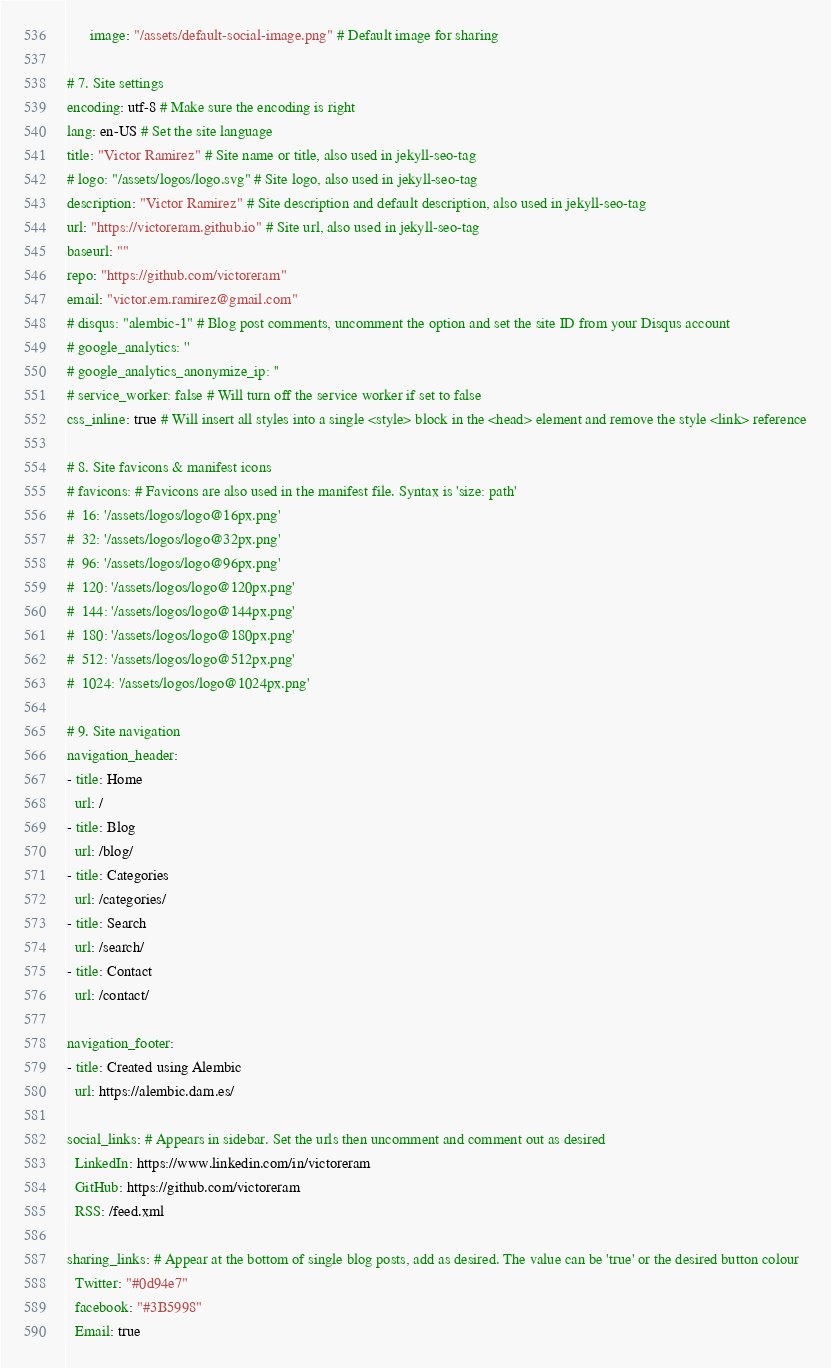<code> <loc_0><loc_0><loc_500><loc_500><_YAML_>      image: "/assets/default-social-image.png" # Default image for sharing

# 7. Site settings
encoding: utf-8 # Make sure the encoding is right
lang: en-US # Set the site language
title: "Victor Ramirez" # Site name or title, also used in jekyll-seo-tag
# logo: "/assets/logos/logo.svg" # Site logo, also used in jekyll-seo-tag
description: "Victor Ramirez" # Site description and default description, also used in jekyll-seo-tag
url: "https://victoreram.github.io" # Site url, also used in jekyll-seo-tag
baseurl: ""
repo: "https://github.com/victoreram"
email: "victor.em.ramirez@gmail.com"
# disqus: "alembic-1" # Blog post comments, uncomment the option and set the site ID from your Disqus account
# google_analytics: ''
# google_analytics_anonymize_ip: ''
# service_worker: false # Will turn off the service worker if set to false
css_inline: true # Will insert all styles into a single <style> block in the <head> element and remove the style <link> reference

# 8. Site favicons & manifest icons
# favicons: # Favicons are also used in the manifest file. Syntax is 'size: path'
#  16: '/assets/logos/logo@16px.png'
#  32: '/assets/logos/logo@32px.png'
#  96: '/assets/logos/logo@96px.png'
#  120: '/assets/logos/logo@120px.png'
#  144: '/assets/logos/logo@144px.png'
#  180: '/assets/logos/logo@180px.png'
#  512: '/assets/logos/logo@512px.png'
#  1024: '/assets/logos/logo@1024px.png'

# 9. Site navigation
navigation_header:
- title: Home
  url: /
- title: Blog
  url: /blog/
- title: Categories
  url: /categories/
- title: Search
  url: /search/
- title: Contact
  url: /contact/

navigation_footer:
- title: Created using Alembic
  url: https://alembic.darn.es/

social_links: # Appears in sidebar. Set the urls then uncomment and comment out as desired
  LinkedIn: https://www.linkedin.com/in/victoreram
  GitHub: https://github.com/victoreram
  RSS: /feed.xml

sharing_links: # Appear at the bottom of single blog posts, add as desired. The value can be 'true' or the desired button colour
  Twitter: "#0d94e7"
  facebook: "#3B5998"
  Email: true
</code> 